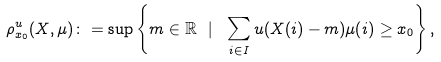Convert formula to latex. <formula><loc_0><loc_0><loc_500><loc_500>\rho _ { x _ { 0 } } ^ { u } ( X , \mu ) \colon = \sup \left \{ m \in \mathbb { R } \ | \ \sum _ { i \in I } u ( X ( i ) - m ) \mu ( i ) \geq x _ { 0 } \right \} ,</formula> 